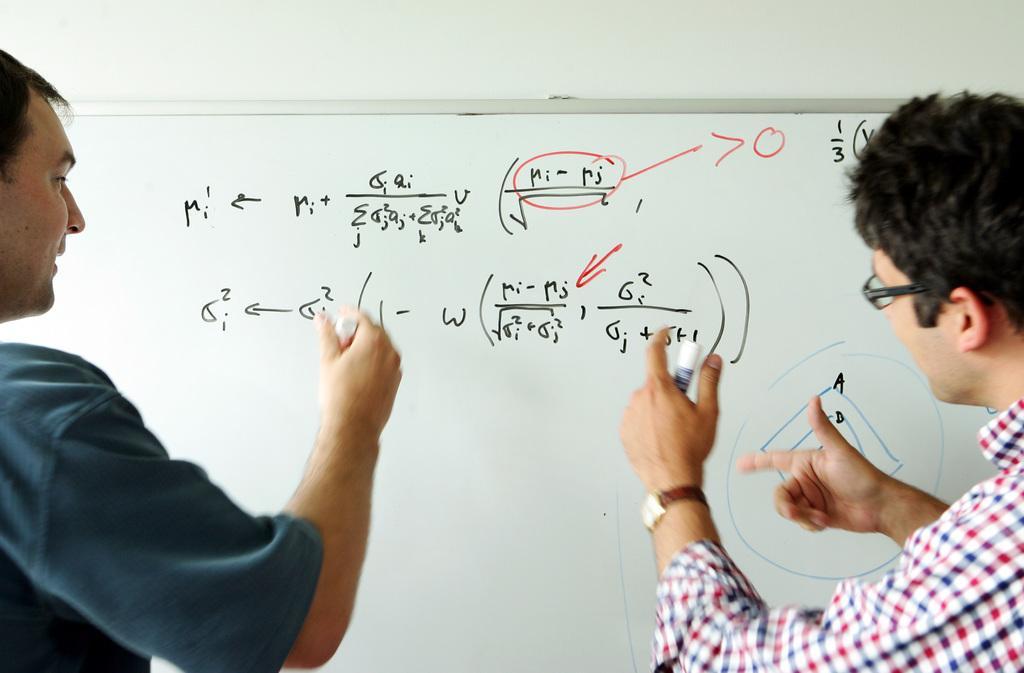Could you give a brief overview of what you see in this image? In the foreground of the picture there are two men holding markers. In the center of the picture there is a board, on the board there is text. 